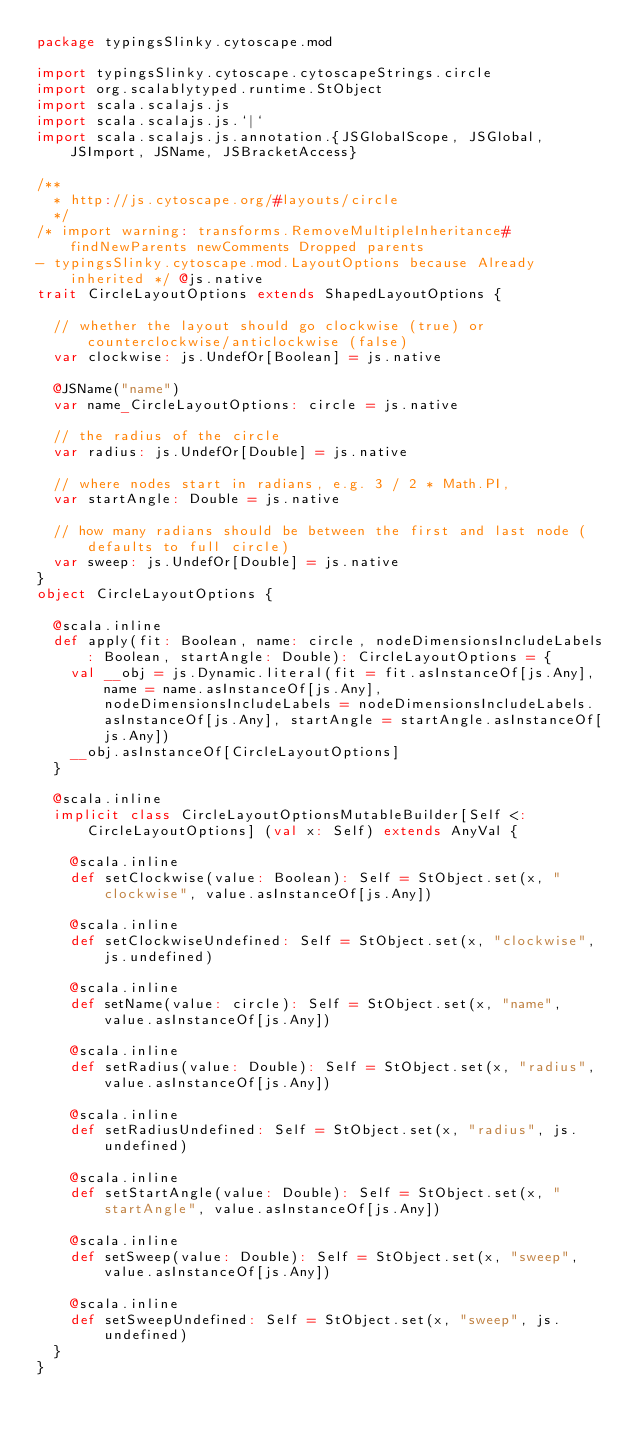<code> <loc_0><loc_0><loc_500><loc_500><_Scala_>package typingsSlinky.cytoscape.mod

import typingsSlinky.cytoscape.cytoscapeStrings.circle
import org.scalablytyped.runtime.StObject
import scala.scalajs.js
import scala.scalajs.js.`|`
import scala.scalajs.js.annotation.{JSGlobalScope, JSGlobal, JSImport, JSName, JSBracketAccess}

/**
  * http://js.cytoscape.org/#layouts/circle
  */
/* import warning: transforms.RemoveMultipleInheritance#findNewParents newComments Dropped parents 
- typingsSlinky.cytoscape.mod.LayoutOptions because Already inherited */ @js.native
trait CircleLayoutOptions extends ShapedLayoutOptions {
  
  // whether the layout should go clockwise (true) or counterclockwise/anticlockwise (false)
  var clockwise: js.UndefOr[Boolean] = js.native
  
  @JSName("name")
  var name_CircleLayoutOptions: circle = js.native
  
  // the radius of the circle
  var radius: js.UndefOr[Double] = js.native
  
  // where nodes start in radians, e.g. 3 / 2 * Math.PI,
  var startAngle: Double = js.native
  
  // how many radians should be between the first and last node (defaults to full circle)
  var sweep: js.UndefOr[Double] = js.native
}
object CircleLayoutOptions {
  
  @scala.inline
  def apply(fit: Boolean, name: circle, nodeDimensionsIncludeLabels: Boolean, startAngle: Double): CircleLayoutOptions = {
    val __obj = js.Dynamic.literal(fit = fit.asInstanceOf[js.Any], name = name.asInstanceOf[js.Any], nodeDimensionsIncludeLabels = nodeDimensionsIncludeLabels.asInstanceOf[js.Any], startAngle = startAngle.asInstanceOf[js.Any])
    __obj.asInstanceOf[CircleLayoutOptions]
  }
  
  @scala.inline
  implicit class CircleLayoutOptionsMutableBuilder[Self <: CircleLayoutOptions] (val x: Self) extends AnyVal {
    
    @scala.inline
    def setClockwise(value: Boolean): Self = StObject.set(x, "clockwise", value.asInstanceOf[js.Any])
    
    @scala.inline
    def setClockwiseUndefined: Self = StObject.set(x, "clockwise", js.undefined)
    
    @scala.inline
    def setName(value: circle): Self = StObject.set(x, "name", value.asInstanceOf[js.Any])
    
    @scala.inline
    def setRadius(value: Double): Self = StObject.set(x, "radius", value.asInstanceOf[js.Any])
    
    @scala.inline
    def setRadiusUndefined: Self = StObject.set(x, "radius", js.undefined)
    
    @scala.inline
    def setStartAngle(value: Double): Self = StObject.set(x, "startAngle", value.asInstanceOf[js.Any])
    
    @scala.inline
    def setSweep(value: Double): Self = StObject.set(x, "sweep", value.asInstanceOf[js.Any])
    
    @scala.inline
    def setSweepUndefined: Self = StObject.set(x, "sweep", js.undefined)
  }
}
</code> 